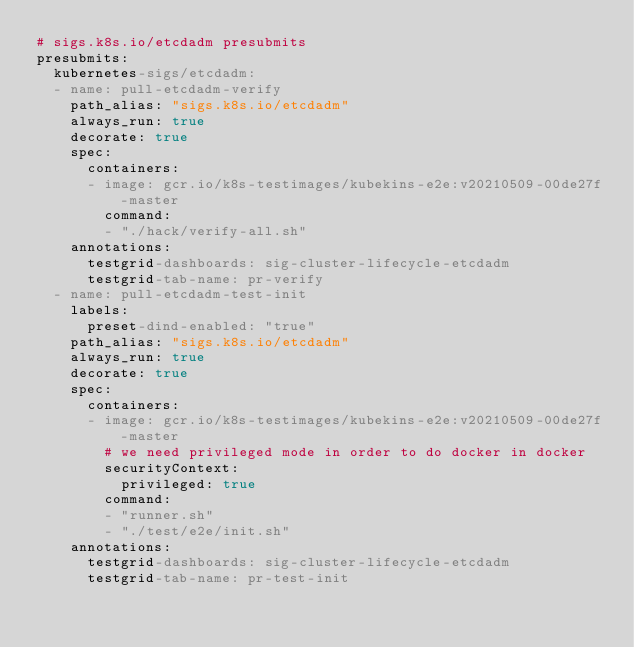<code> <loc_0><loc_0><loc_500><loc_500><_YAML_># sigs.k8s.io/etcdadm presubmits
presubmits:
  kubernetes-sigs/etcdadm:
  - name: pull-etcdadm-verify
    path_alias: "sigs.k8s.io/etcdadm"
    always_run: true
    decorate: true
    spec:
      containers:
      - image: gcr.io/k8s-testimages/kubekins-e2e:v20210509-00de27f-master
        command:
        - "./hack/verify-all.sh"
    annotations:
      testgrid-dashboards: sig-cluster-lifecycle-etcdadm
      testgrid-tab-name: pr-verify
  - name: pull-etcdadm-test-init
    labels:
      preset-dind-enabled: "true"
    path_alias: "sigs.k8s.io/etcdadm"
    always_run: true
    decorate: true
    spec:
      containers:
      - image: gcr.io/k8s-testimages/kubekins-e2e:v20210509-00de27f-master
        # we need privileged mode in order to do docker in docker
        securityContext:
          privileged: true
        command:
        - "runner.sh"
        - "./test/e2e/init.sh"
    annotations:
      testgrid-dashboards: sig-cluster-lifecycle-etcdadm
      testgrid-tab-name: pr-test-init
</code> 